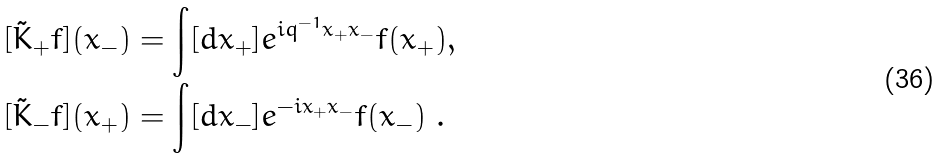Convert formula to latex. <formula><loc_0><loc_0><loc_500><loc_500>[ \tilde { K } _ { + } f ] ( x _ { - } ) & = \int [ d x _ { + } ] e ^ { i q ^ { - 1 } x _ { + } x _ { - } } f ( x _ { + } ) , \\ [ \tilde { K } _ { - } f ] ( x _ { + } ) & = \int [ d x _ { - } ] e ^ { - i x _ { + } x _ { - } } f ( x _ { - } ) \ .</formula> 